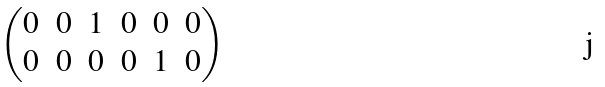<formula> <loc_0><loc_0><loc_500><loc_500>\begin{pmatrix} 0 & 0 & 1 & 0 & 0 & 0 \\ 0 & 0 & 0 & 0 & 1 & 0 \end{pmatrix}</formula> 